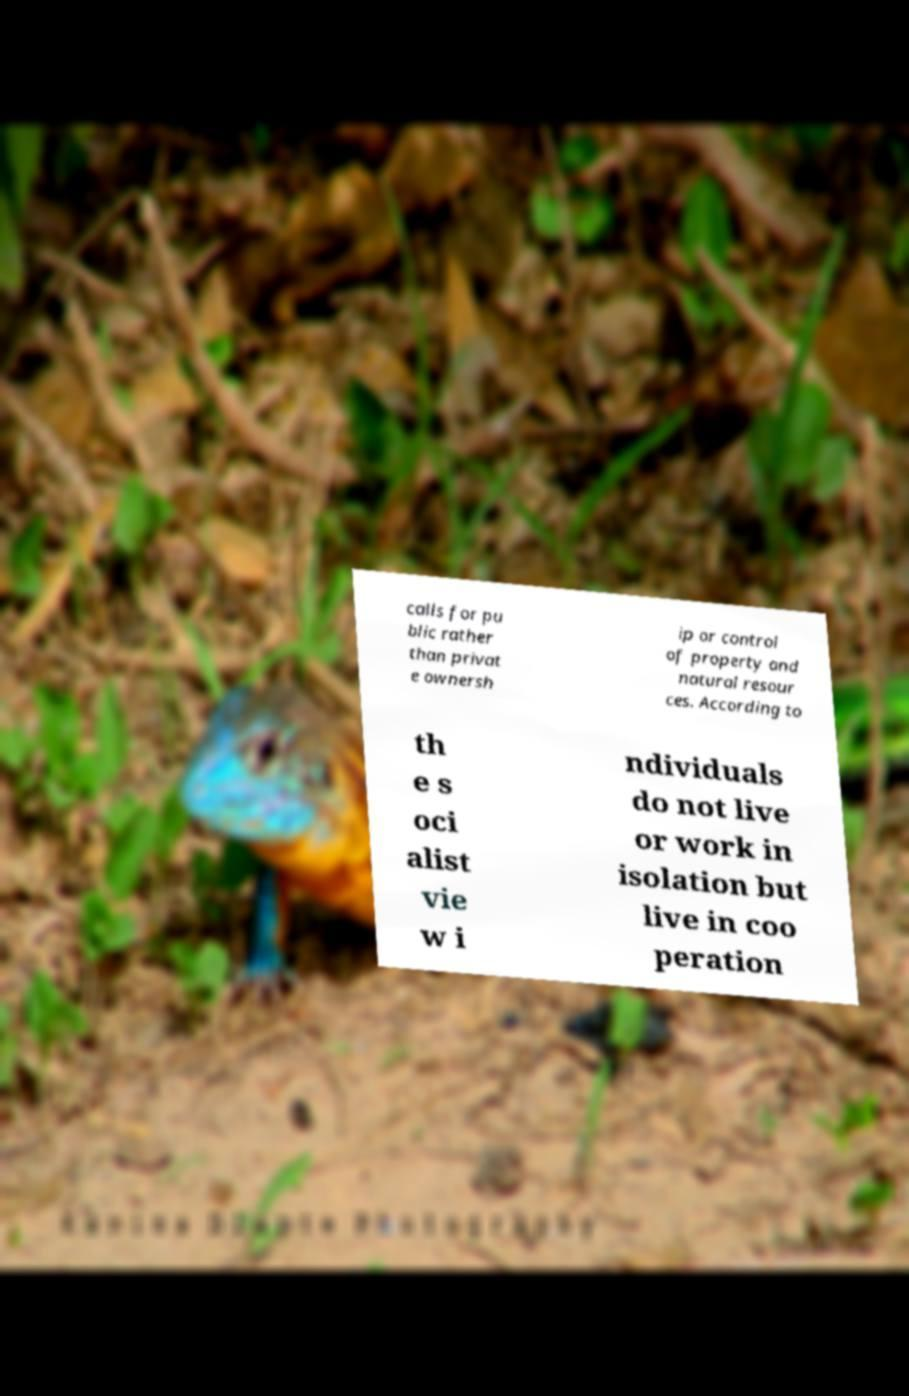Please identify and transcribe the text found in this image. calls for pu blic rather than privat e ownersh ip or control of property and natural resour ces. According to th e s oci alist vie w i ndividuals do not live or work in isolation but live in coo peration 